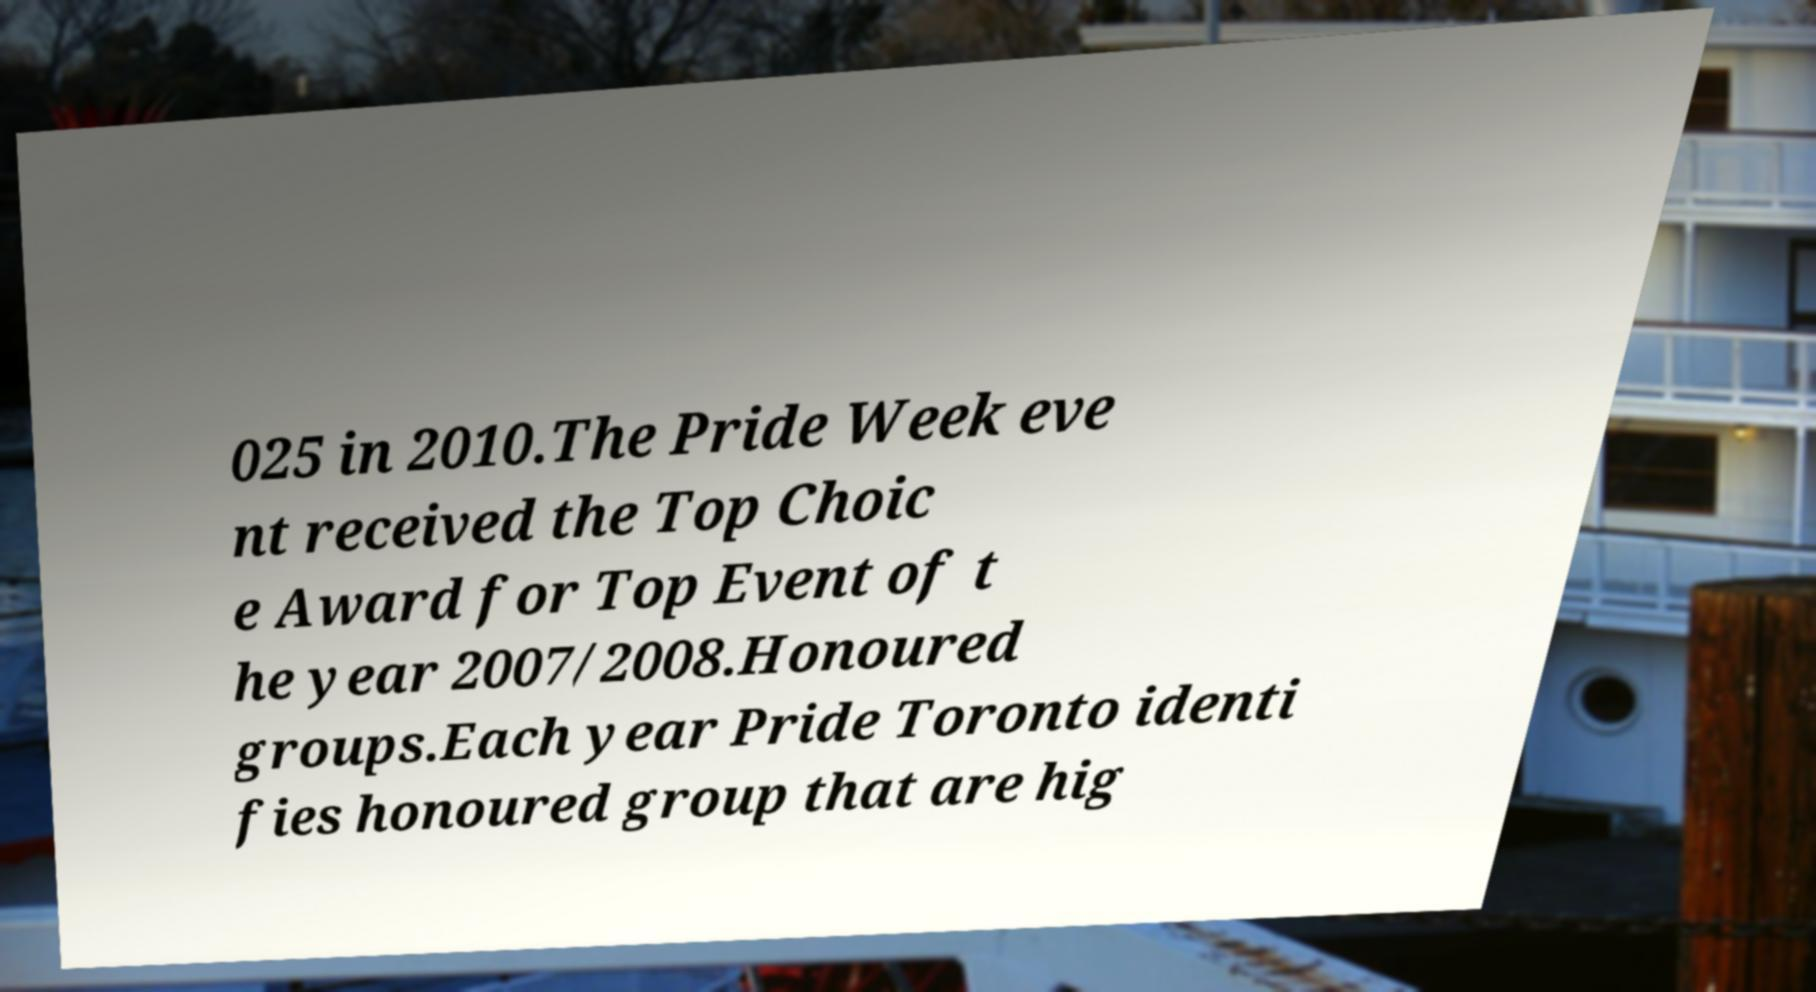For documentation purposes, I need the text within this image transcribed. Could you provide that? 025 in 2010.The Pride Week eve nt received the Top Choic e Award for Top Event of t he year 2007/2008.Honoured groups.Each year Pride Toronto identi fies honoured group that are hig 